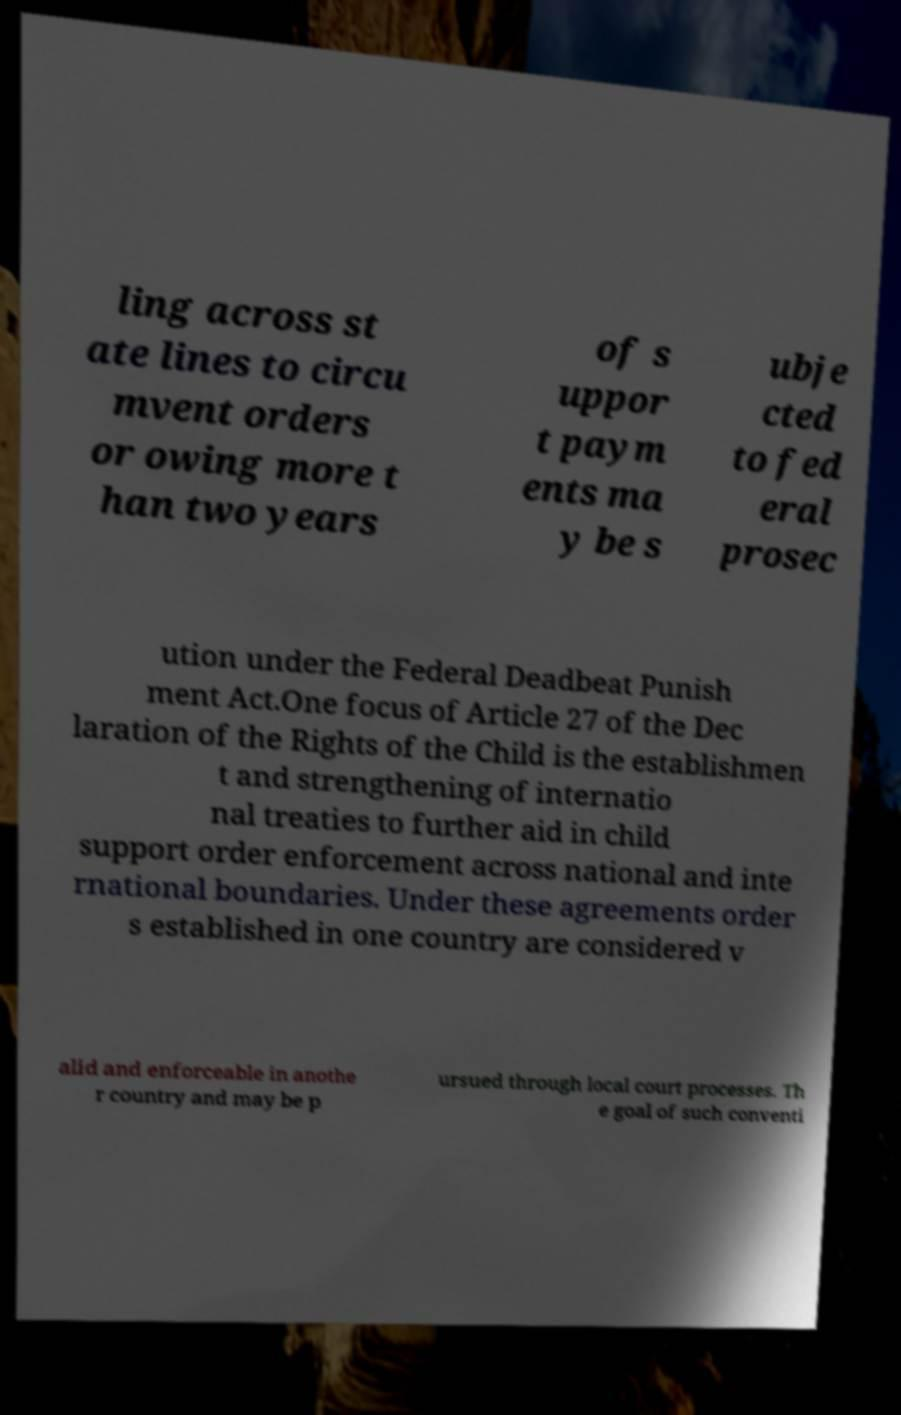Could you extract and type out the text from this image? ling across st ate lines to circu mvent orders or owing more t han two years of s uppor t paym ents ma y be s ubje cted to fed eral prosec ution under the Federal Deadbeat Punish ment Act.One focus of Article 27 of the Dec laration of the Rights of the Child is the establishmen t and strengthening of internatio nal treaties to further aid in child support order enforcement across national and inte rnational boundaries. Under these agreements order s established in one country are considered v alid and enforceable in anothe r country and may be p ursued through local court processes. Th e goal of such conventi 